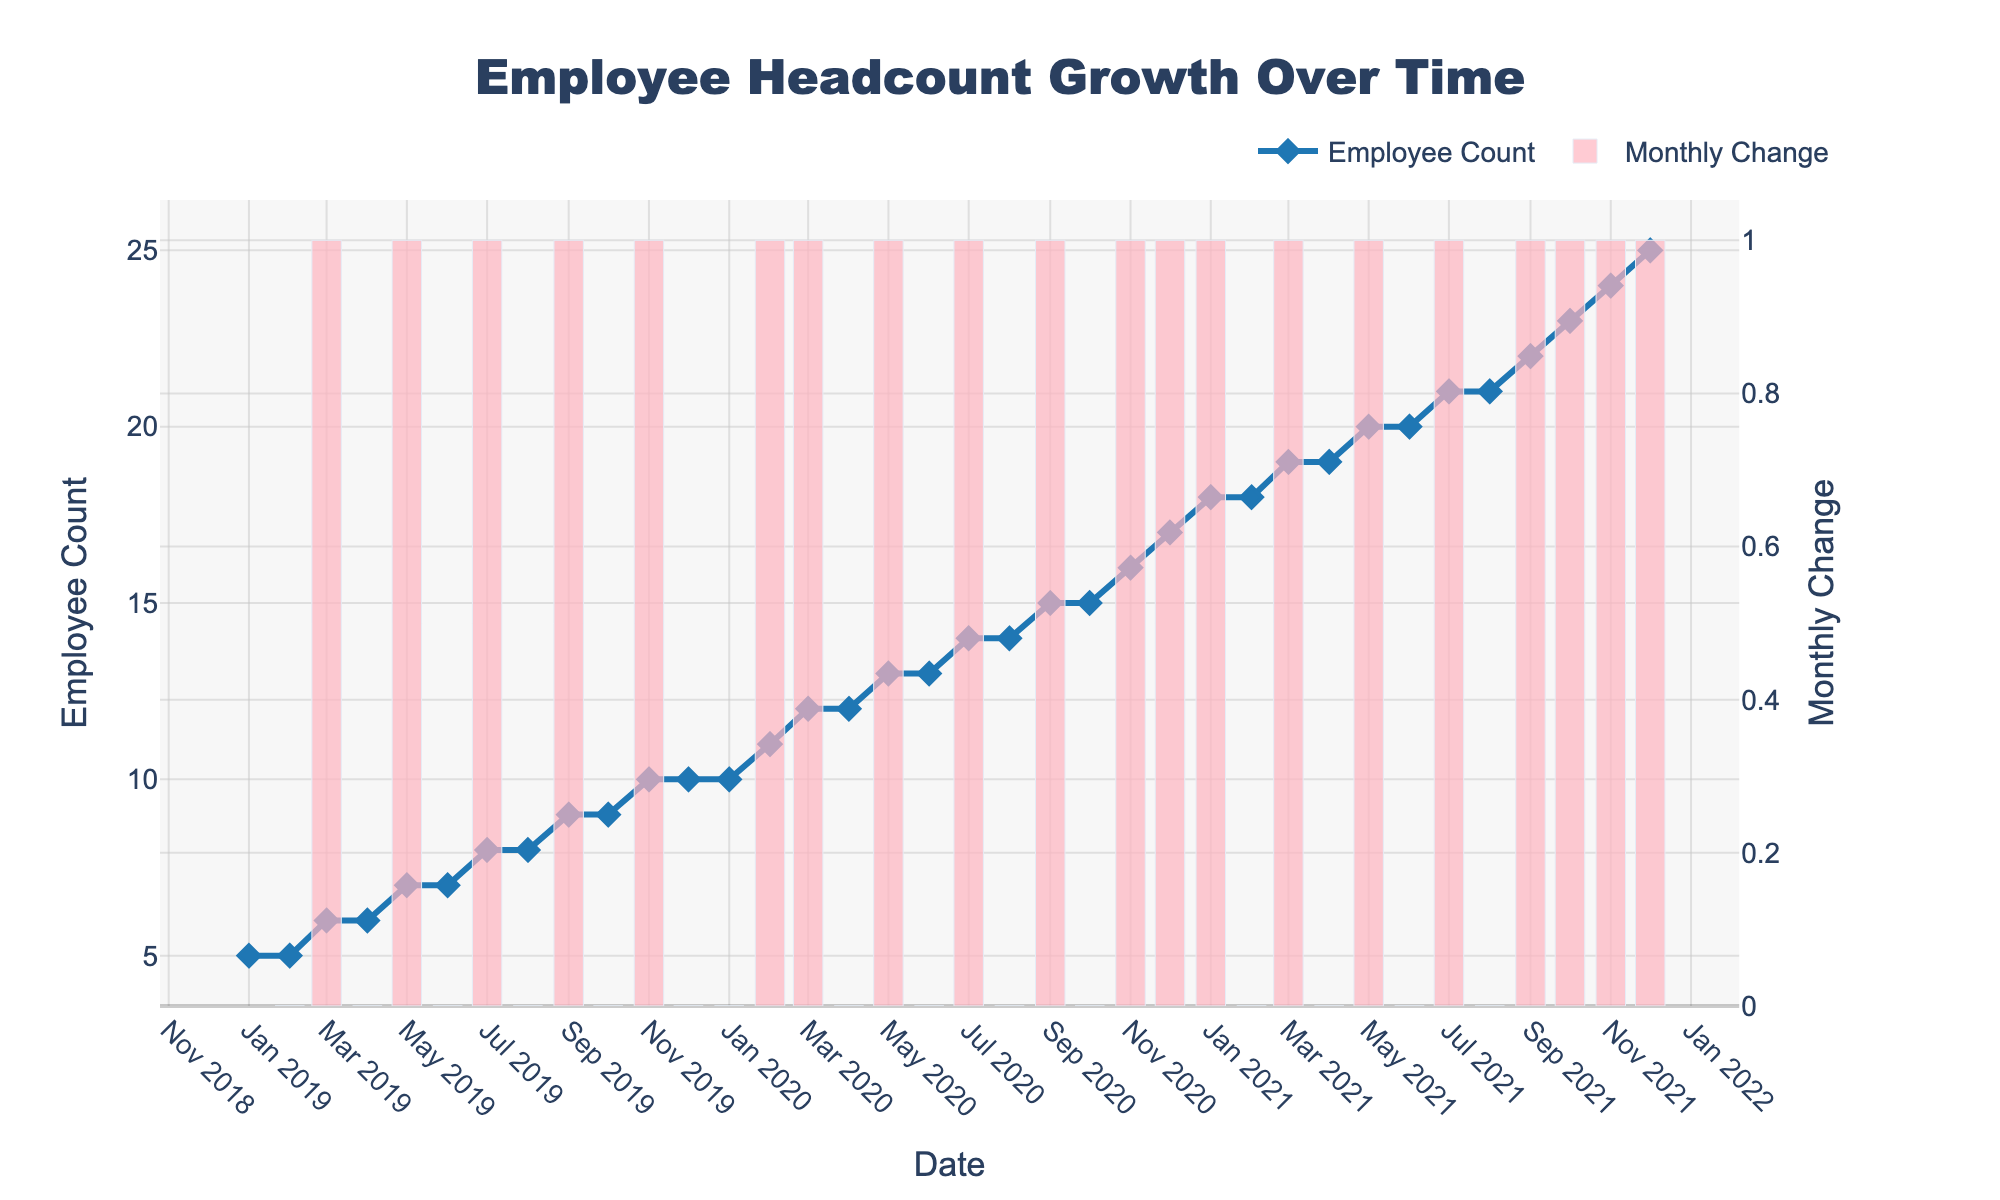What is the title of the plot? The title of the plot is usually displayed at the top of the figure. Using this, we can see that the title reads "Employee Headcount Growth Over Time."
Answer: Employee Headcount Growth Over Time How many employees were there in January 2020? To find how many employees were there in January 2020, look for the data point corresponding to January 2020 on the x-axis, then check the y-axis value for "Employee Count."
Answer: 10 What is the color of the line representing the Employee Count? The color of the line representing the Employee Count is visually identifiable in the plot, which is blue.
Answer: Blue What is the general trend of employee count from January 2019 to December 2021? Observing the line plot from January 2019 to December 2021, the employee count continuously increases over the years.
Answer: Increasing What was the monthly change in employee count for March 2019? The plot includes bars showing monthly changes. For March 2019, locate the bar corresponding to this month and note its height. The bar for March 2019 shows a positive change of 1.
Answer: +1 By how much did the employee count increase from December 2019 to December 2020? Find the employee count for both December 2019 and December 2020, then calculate the difference. The values are 10 and 17, respectively. So, 17 - 10 = 7.
Answer: 7 Which month in 2020 had the highest monthly change in employee count? By looking at the monthly change bars for each month in 2020, the highest bar can be found in November 2020.
Answer: November 2020 Compare the employee count growth between the years 2019 and 2020. The employee count in January 2019 was 5 and in December 2019 was 10, indicating an increase of 5. In January 2020, it was 10, and in December 2020, it was 17, indicating an increase of 7.
Answer: 2020 had higher growth What is the trend in monthly change from mid-2021? Look at the bar plot starting around mid-2021, the trend shows a series of consistent positive monthly changes.
Answer: Consistent positive changes How often did the employee count remain the same from one month to the next? Observe the bars representing monthly changes; identify bars with zero height (indicating no change). This occurred a few times, such as February to March 2019, March to April 2020.
Answer: Several times 